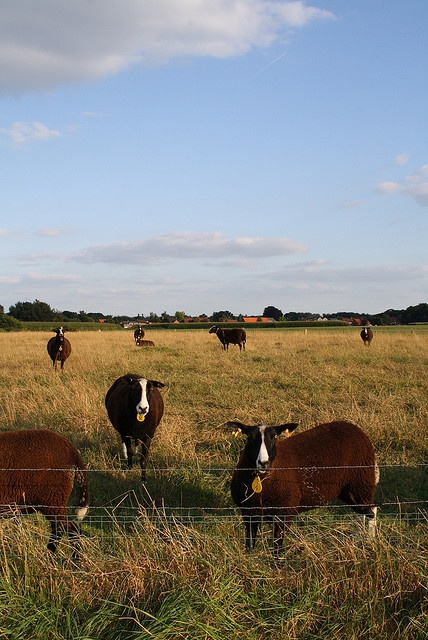Describe the objects in this image and their specific colors. I can see sheep in darkgray, black, maroon, olive, and gray tones, sheep in darkgray, black, maroon, and gray tones, sheep in darkgray, black, maroon, olive, and tan tones, sheep in darkgray, black, maroon, and brown tones, and sheep in darkgray, black, maroon, and tan tones in this image. 